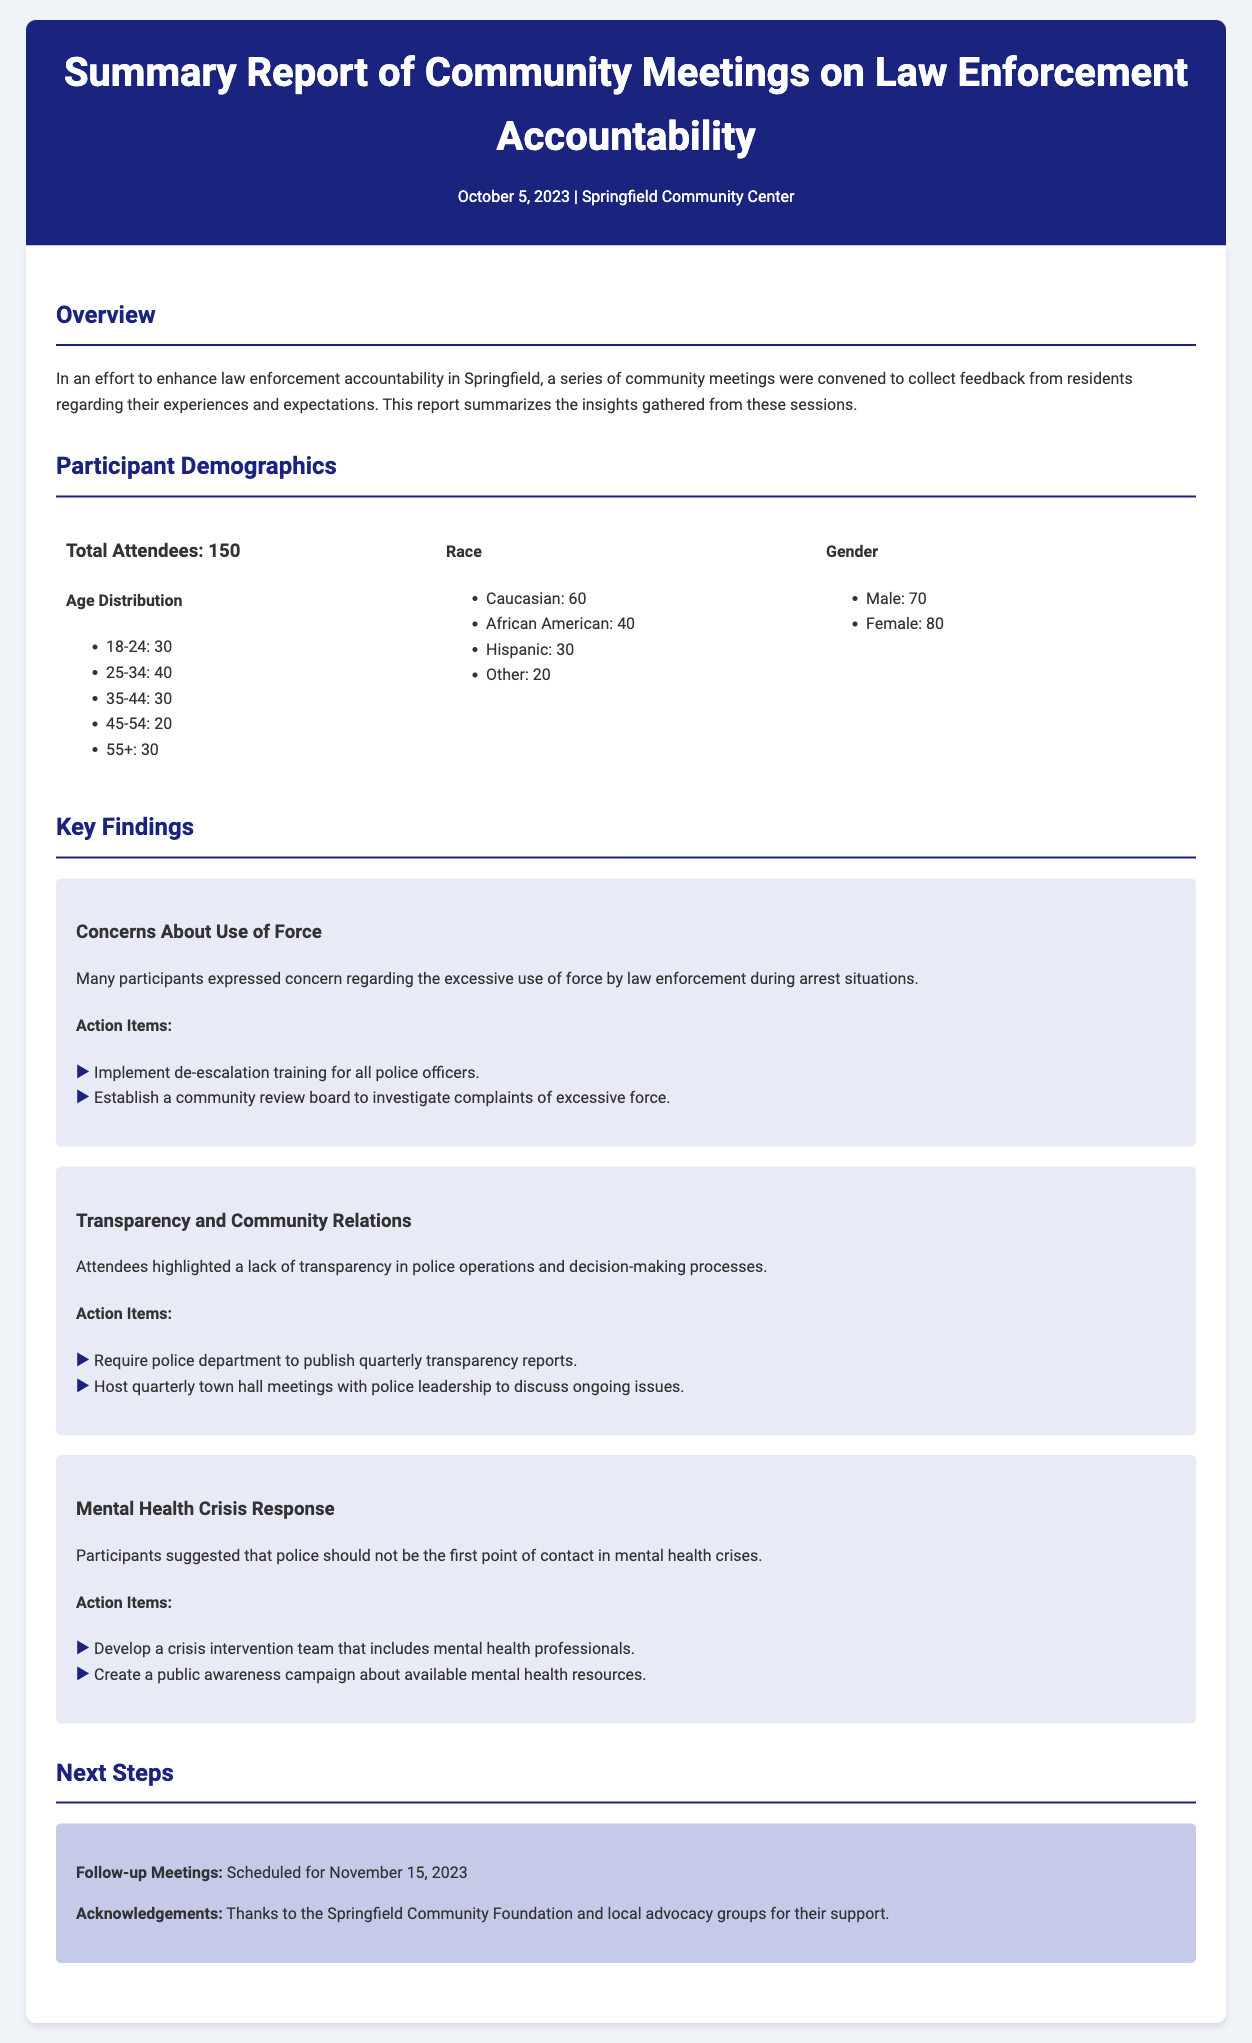what was the date of the community meetings? The document specifies that the meetings were held on October 5, 2023.
Answer: October 5, 2023 how many total attendees were there? The participant demographics section states that there were 150 total attendees.
Answer: 150 what action item was suggested for mental health crisis response? The findings indicate that one action item is to develop a crisis intervention team that includes mental health professionals.
Answer: Develop a crisis intervention team which age group had the highest attendance? The age distribution shows that the 25-34 age group had the highest number of attendees, with 40 participants.
Answer: 25-34 how many people identified as African American? The demographics section lists 40 attendees as African American.
Answer: 40 what are the next steps mentioned in the report? The next steps include follow-up meetings scheduled for November 15, 2023.
Answer: November 15, 2023 what is one concern raised about law enforcement by participants? Participants expressed concern regarding the excessive use of force by law enforcement during arrest situations.
Answer: Excessive use of force how many action items were listed under transparency and community relations? Under the transparency and community relations section, there are two action items listed.
Answer: Two 